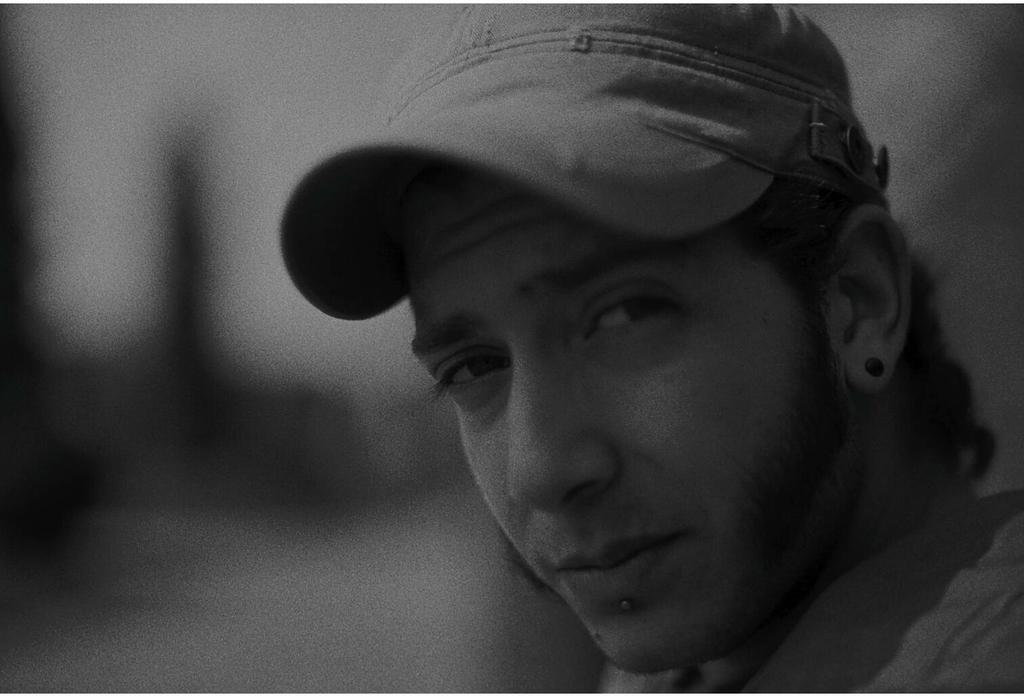What is the main subject of the image? The main subject of the image is a man. Can you describe what the man is wearing on his head? The man is wearing a hat. What can be observed about the background of the image? The background of the image is blurred. Can you tell me how many cats are sitting in the shade in the image? There are no cats present in the image, and therefore no such activity can be observed. 